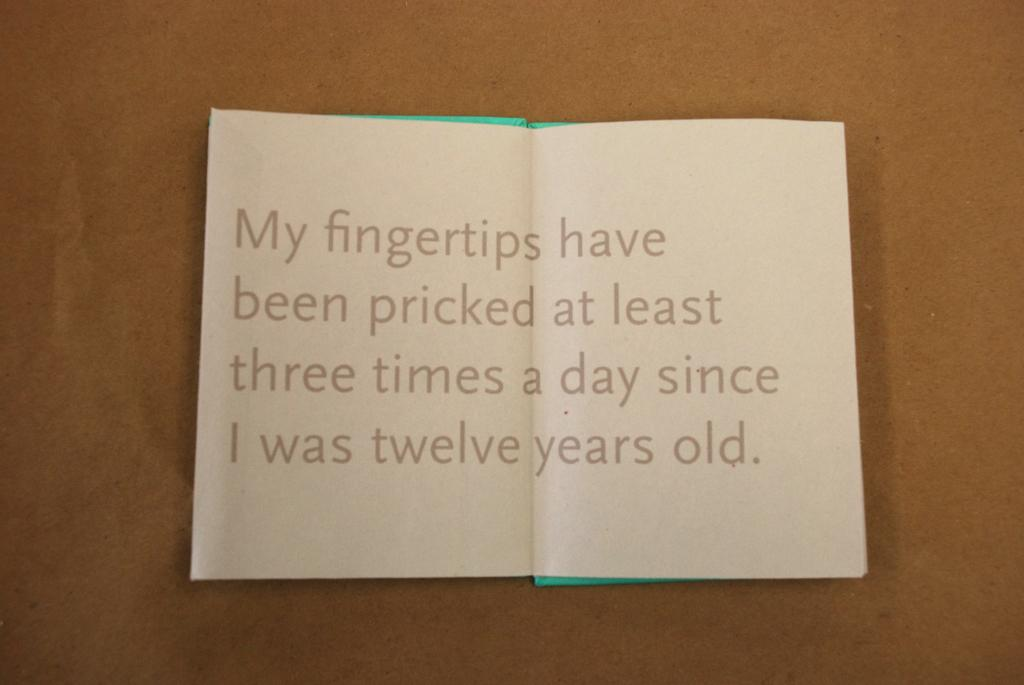<image>
Summarize the visual content of the image. Sheet of paper that is saying that a person has had their fingers pricked 3 times a day since they was twelve years old. 